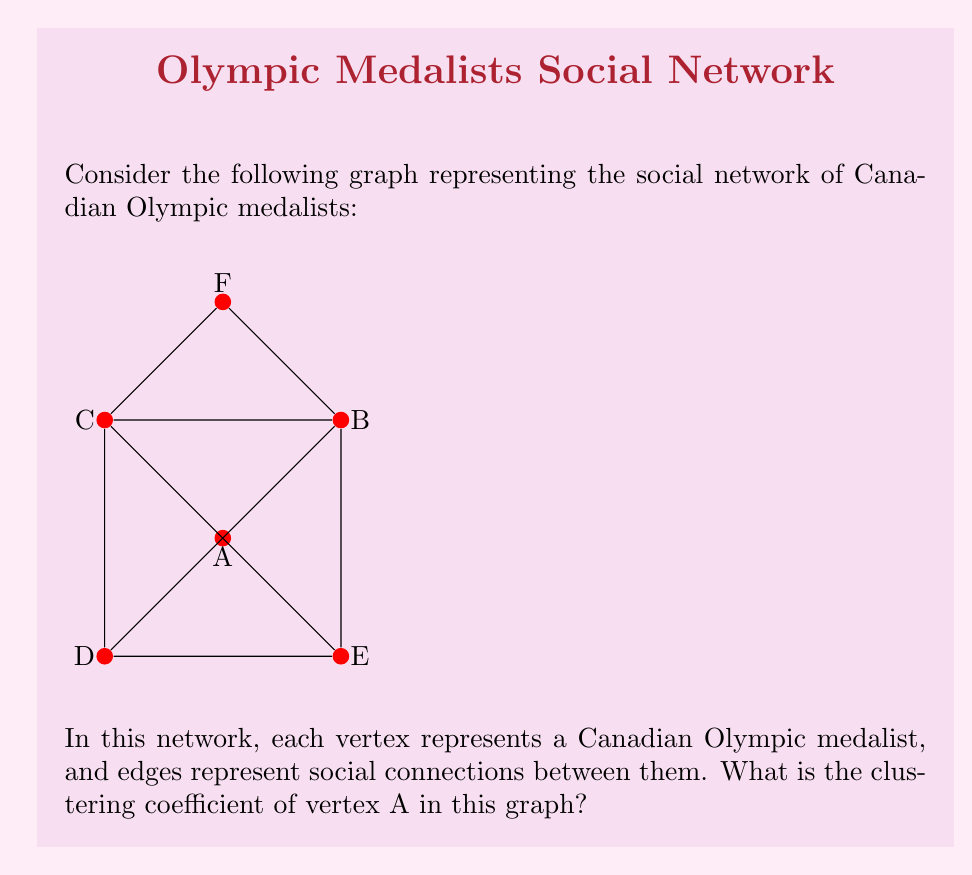Teach me how to tackle this problem. To solve this problem, we'll follow these steps:

1) First, recall the definition of clustering coefficient for a vertex:
   $C_v = \frac{2 \times E}{k(k-1)}$
   where $E$ is the number of edges between the neighbors of the vertex, and $k$ is the number of neighbors.

2) For vertex A:
   - Count the number of neighbors (degree): $k = 4$ (B, C, D, E)
   - Count the number of edges between these neighbors: $E = 6$ (B-C, B-D, B-E, C-D, C-E, D-E)

3) Plug these values into the formula:

   $C_A = \frac{2 \times 6}{4(4-1)} = \frac{12}{12} = 1$

4) Therefore, the clustering coefficient of vertex A is 1, which means all possible connections between A's neighbors exist, forming a complete subgraph (clique).

This high clustering coefficient indicates that Canadian Olympic medalists in A's immediate network are all connected, suggesting a tight-knit community among these athletes.
Answer: 1 